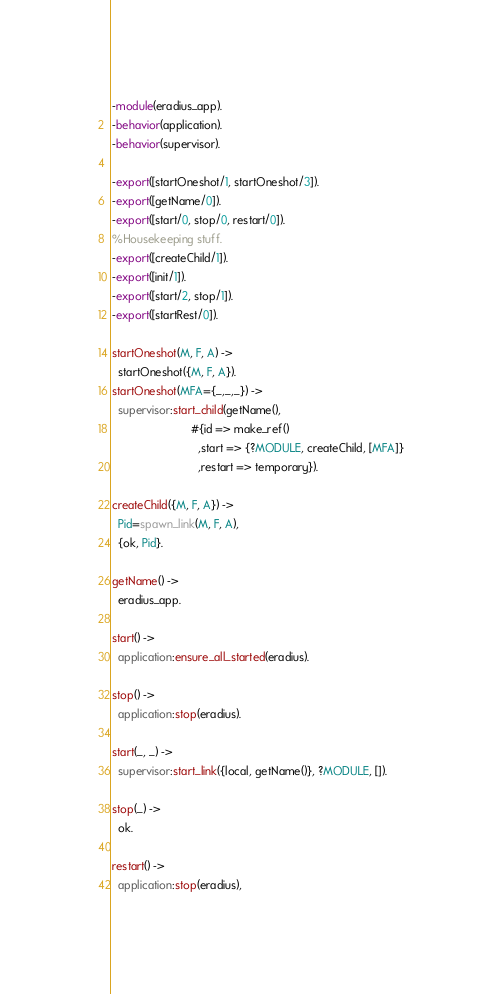<code> <loc_0><loc_0><loc_500><loc_500><_Erlang_>-module(eradius_app).
-behavior(application).
-behavior(supervisor).

-export([startOneshot/1, startOneshot/3]).
-export([getName/0]).
-export([start/0, stop/0, restart/0]).
%Housekeeping stuff.
-export([createChild/1]).
-export([init/1]).
-export([start/2, stop/1]).
-export([startRest/0]).

startOneshot(M, F, A) ->
  startOneshot({M, F, A}).
startOneshot(MFA={_,_,_}) ->
  supervisor:start_child(getName(),
                         #{id => make_ref()
                           ,start => {?MODULE, createChild, [MFA]}
                           ,restart => temporary}).

createChild({M, F, A}) ->
  Pid=spawn_link(M, F, A),
  {ok, Pid}.

getName() ->
  eradius_app.

start() ->
  application:ensure_all_started(eradius).

stop() ->
  application:stop(eradius).

start(_, _) ->
  supervisor:start_link({local, getName()}, ?MODULE, []).

stop(_) ->
  ok.

restart() ->
  application:stop(eradius),</code> 